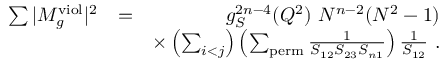<formula> <loc_0><loc_0><loc_500><loc_500>\begin{array} { r l r } { \sum | M _ { g } ^ { v i o l } | ^ { 2 } } & { = } & { g _ { S } ^ { 2 n - 4 } ( Q ^ { 2 } ) N ^ { n - 2 } ( N ^ { 2 } - 1 ) } \\ & { \times \left ( \sum _ { i < j } \right ) \left ( \sum _ { p e r m } \frac { 1 } { S _ { 1 2 } S _ { 2 3 } S _ { n 1 } } \right ) \frac { 1 } { S _ { 1 2 } } . } \end{array}</formula> 